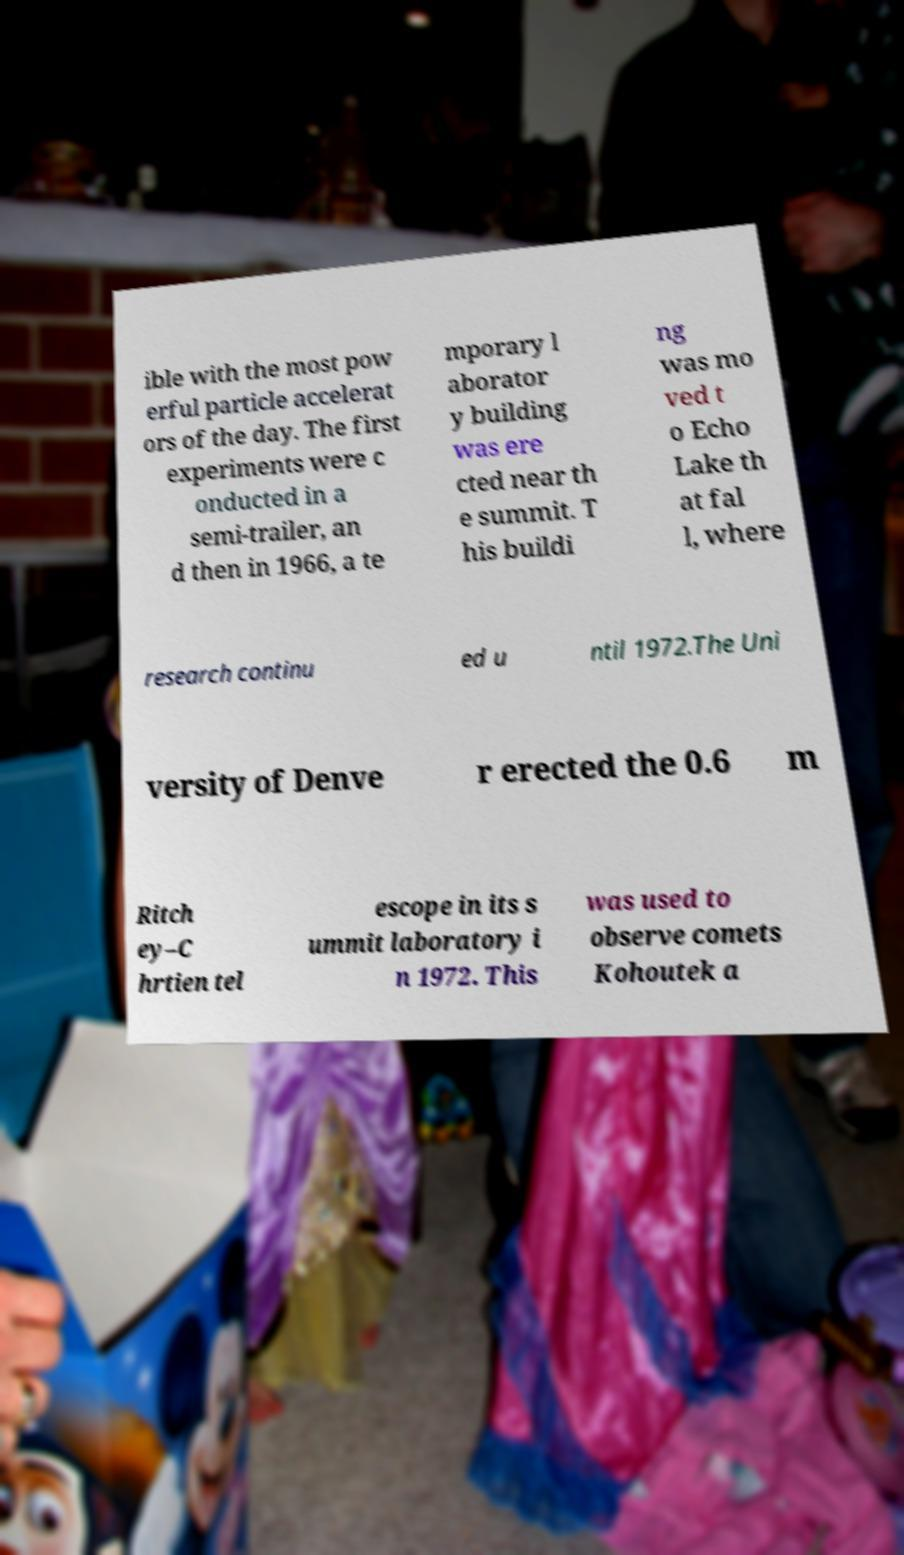Can you read and provide the text displayed in the image?This photo seems to have some interesting text. Can you extract and type it out for me? ible with the most pow erful particle accelerat ors of the day. The first experiments were c onducted in a semi-trailer, an d then in 1966, a te mporary l aborator y building was ere cted near th e summit. T his buildi ng was mo ved t o Echo Lake th at fal l, where research continu ed u ntil 1972.The Uni versity of Denve r erected the 0.6 m Ritch ey–C hrtien tel escope in its s ummit laboratory i n 1972. This was used to observe comets Kohoutek a 